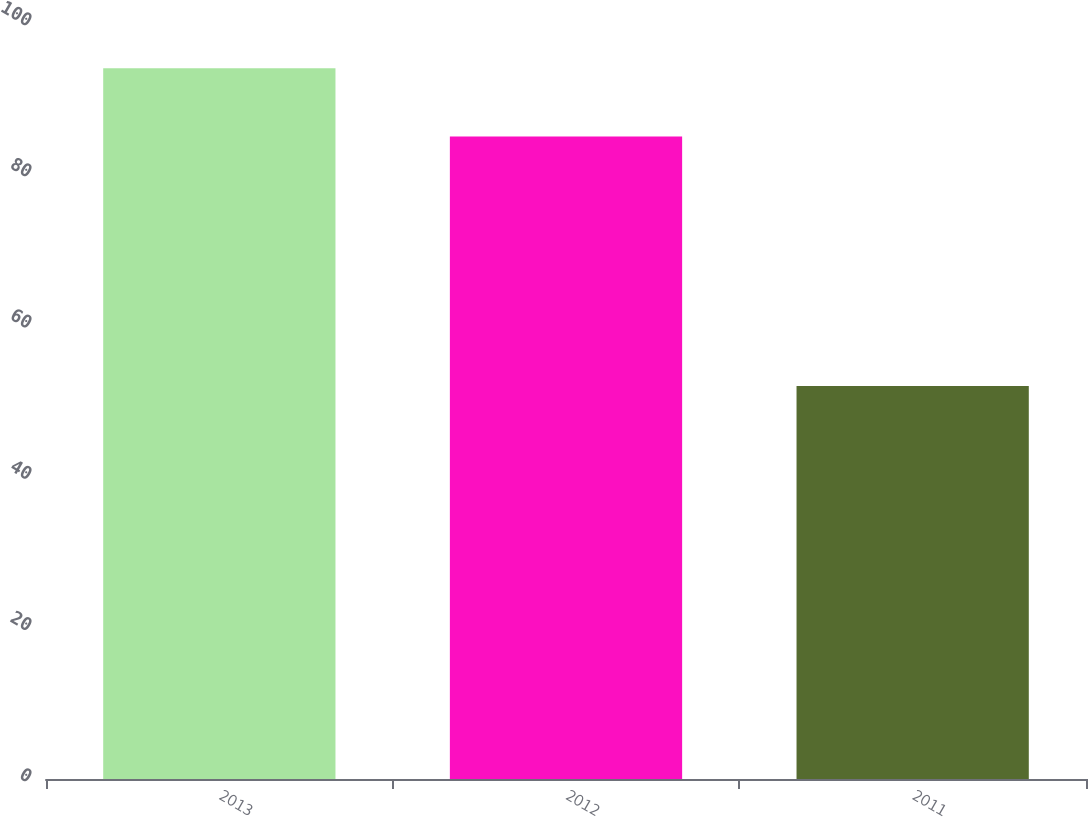Convert chart. <chart><loc_0><loc_0><loc_500><loc_500><bar_chart><fcel>2013<fcel>2012<fcel>2011<nl><fcel>94<fcel>85<fcel>52<nl></chart> 